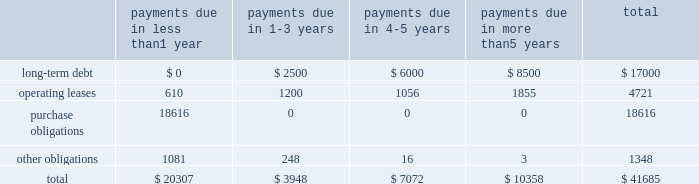Table of contents the table presents certain payments due by the company under contractual obligations with minimum firm commitments as of september 28 , 2013 and excludes amounts already recorded on the consolidated balance sheet , except for long-term debt ( in millions ) : lease commitments the company 2019s major facility leases are typically for terms not exceeding 10 years and generally provide renewal options for terms not exceeding five additional years .
Leases for retail space are for terms ranging from five to 20 years , the majority of which are for 10 years , and often contain multi-year renewal options .
As of september 28 , 2013 , the company 2019s total future minimum lease payments under noncancelable operating leases were $ 4.7 billion , of which $ 3.5 billion related to leases for retail space .
Purchase commitments with outsourcing partners and component suppliers the company utilizes several outsourcing partners to manufacture sub-assemblies for the company 2019s products and to perform final assembly and testing of finished products .
These outsourcing partners acquire components and build product based on demand information supplied by the company , which typically covers periods up to 150 days .
The company also obtains individual components for its products from a wide variety of individual suppliers .
Consistent with industry practice , the company acquires components through a combination of purchase orders , supplier contracts , and open orders based on projected demand information .
Where appropriate , the purchases are applied to inventory component prepayments that are outstanding with the respective supplier .
As of september 28 , 2013 , the company had outstanding off-balance sheet third- party manufacturing commitments and component purchase commitments of $ 18.6 billion .
Other obligations in addition to the off-balance sheet commitments mentioned above , the company had outstanding obligations of $ 1.3 billion as of september 28 , 2013 , that consisted mainly of commitments to acquire capital assets , including product tooling and manufacturing process equipment , and commitments related to advertising , research and development , internet and telecommunications services and other obligations .
The company 2019s other non-current liabilities in the consolidated balance sheets consist primarily of deferred tax liabilities , gross unrecognized tax benefits and the related gross interest and penalties .
As of september 28 , 2013 , the company had non-current deferred tax liabilities of $ 16.5 billion .
Additionally , as of september 28 , 2013 , the company had gross unrecognized tax benefits of $ 2.7 billion and an additional $ 590 million for gross interest and penalties classified as non-current liabilities .
At this time , the company is unable to make a reasonably reliable estimate of the timing of payments in individual years in connection with these tax liabilities ; therefore , such amounts are not included in the above contractual obligation table .
Indemnification the company generally does not indemnify end-users of its operating system and application software against legal claims that the software infringes third-party intellectual property rights .
Other agreements entered into by payments due in than 1 payments due in payments due in payments due in than 5 years total .

As of september 28 , 2013 , the company had non-current deferred tax liabilities of $ 16.5 billion . what was the difference between this and the balance of gross unrecognized tax benefits , in billions? 
Computations: (16.5 - 2.7)
Answer: 13.8. 